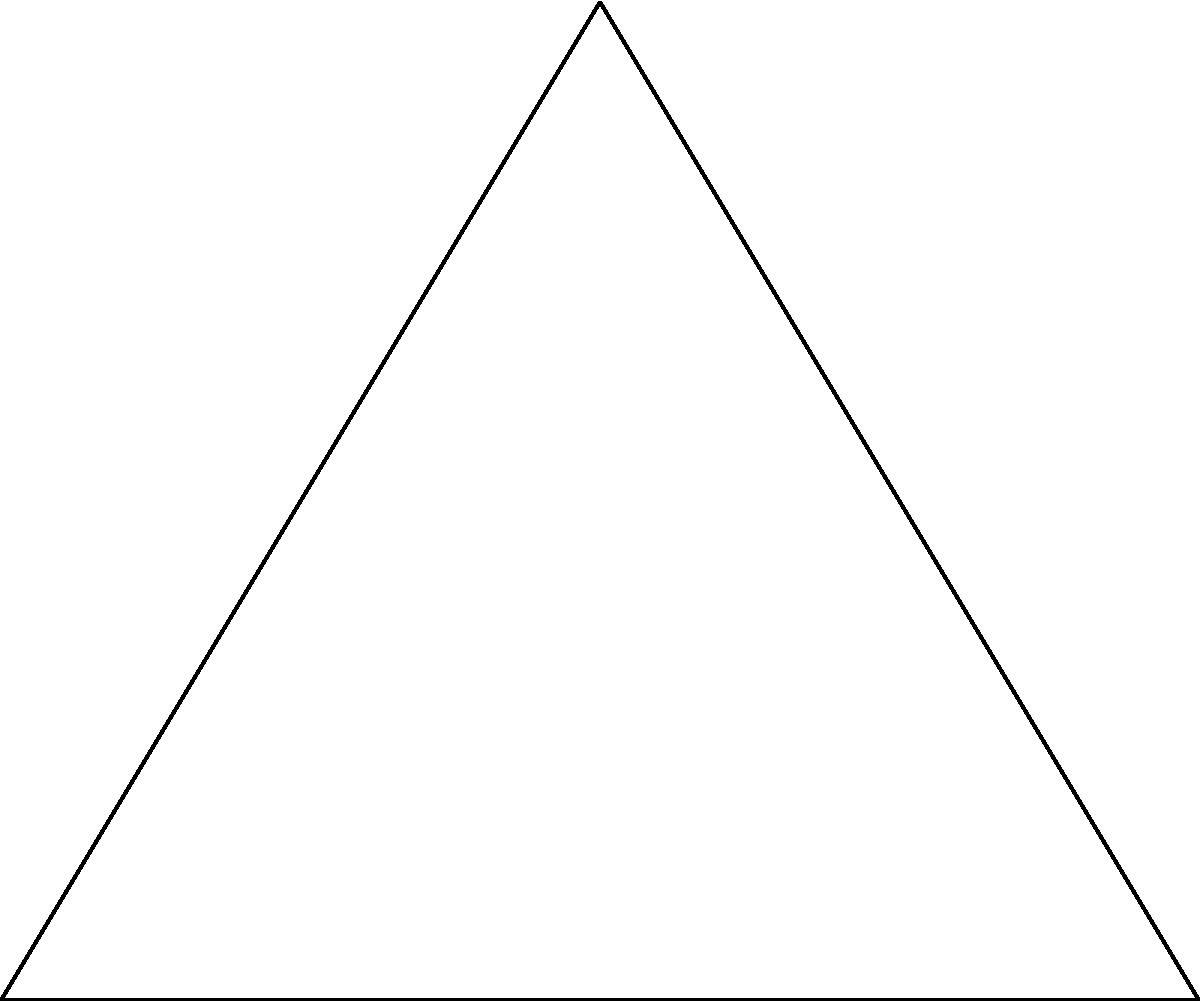A triangular protected green space in Pacifica is represented by triangle ABC. The largest circular area that can be inscribed within this triangle symbolizes a zone of highest ecological importance. If the sides of the triangle are 6 units, 6.71 units, and 8 units long, what is the area of this inscribed circle? To find the area of the inscribed circle, we need to follow these steps:

1) First, we need to calculate the semi-perimeter (s) of the triangle:
   $s = \frac{a + b + c}{2} = \frac{6 + 6.71 + 8}{2} = 10.355$ units

2) The area of the triangle (A) can be found using Heron's formula:
   $A = \sqrt{s(s-a)(s-b)(s-c)}$
   $A = \sqrt{10.355(10.355-6)(10.355-6.71)(10.355-8)}$
   $A = \sqrt{10.355 \times 4.355 \times 3.645 \times 2.355}$
   $A = 16.15$ square units

3) The radius (r) of the inscribed circle can be calculated using the formula:
   $r = \frac{A}{s} = \frac{16.15}{10.355} = 1.56$ units

4) Finally, the area of the inscribed circle is:
   $Area_{circle} = \pi r^2 = \pi (1.56)^2 = 7.64$ square units

Therefore, the area of the inscribed circle representing the zone of highest ecological importance is approximately 7.64 square units.
Answer: $7.64$ square units 